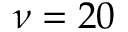<formula> <loc_0><loc_0><loc_500><loc_500>\nu = 2 0</formula> 